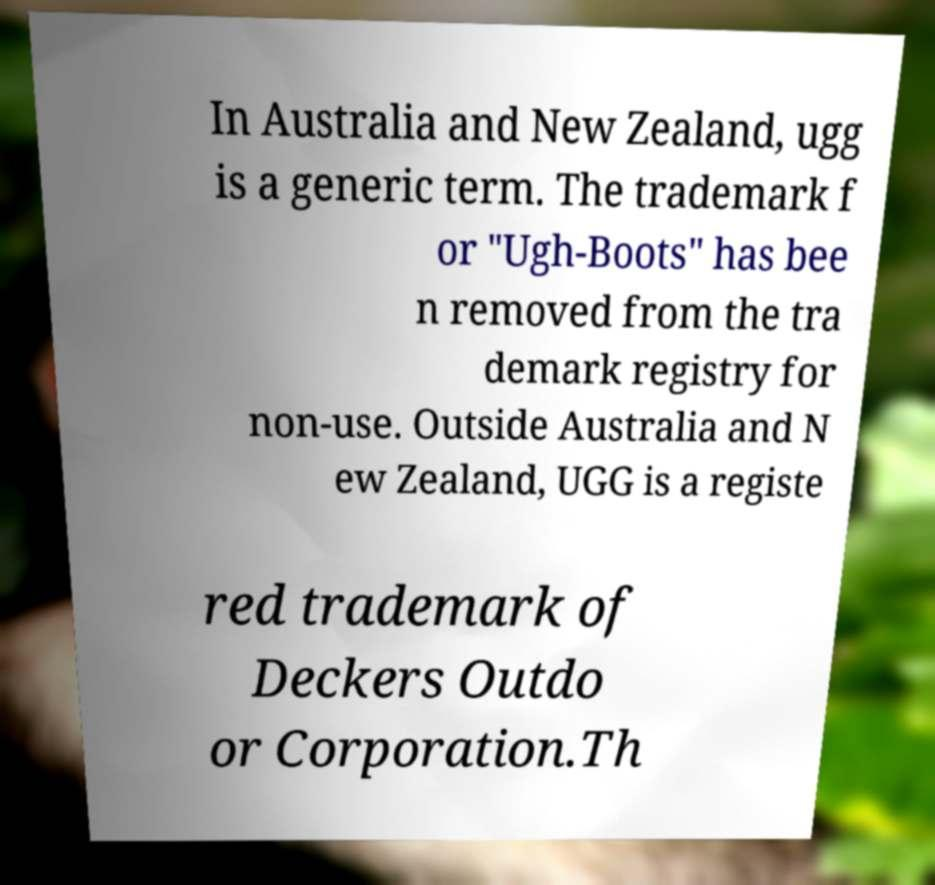Can you accurately transcribe the text from the provided image for me? In Australia and New Zealand, ugg is a generic term. The trademark f or "Ugh-Boots" has bee n removed from the tra demark registry for non-use. Outside Australia and N ew Zealand, UGG is a registe red trademark of Deckers Outdo or Corporation.Th 